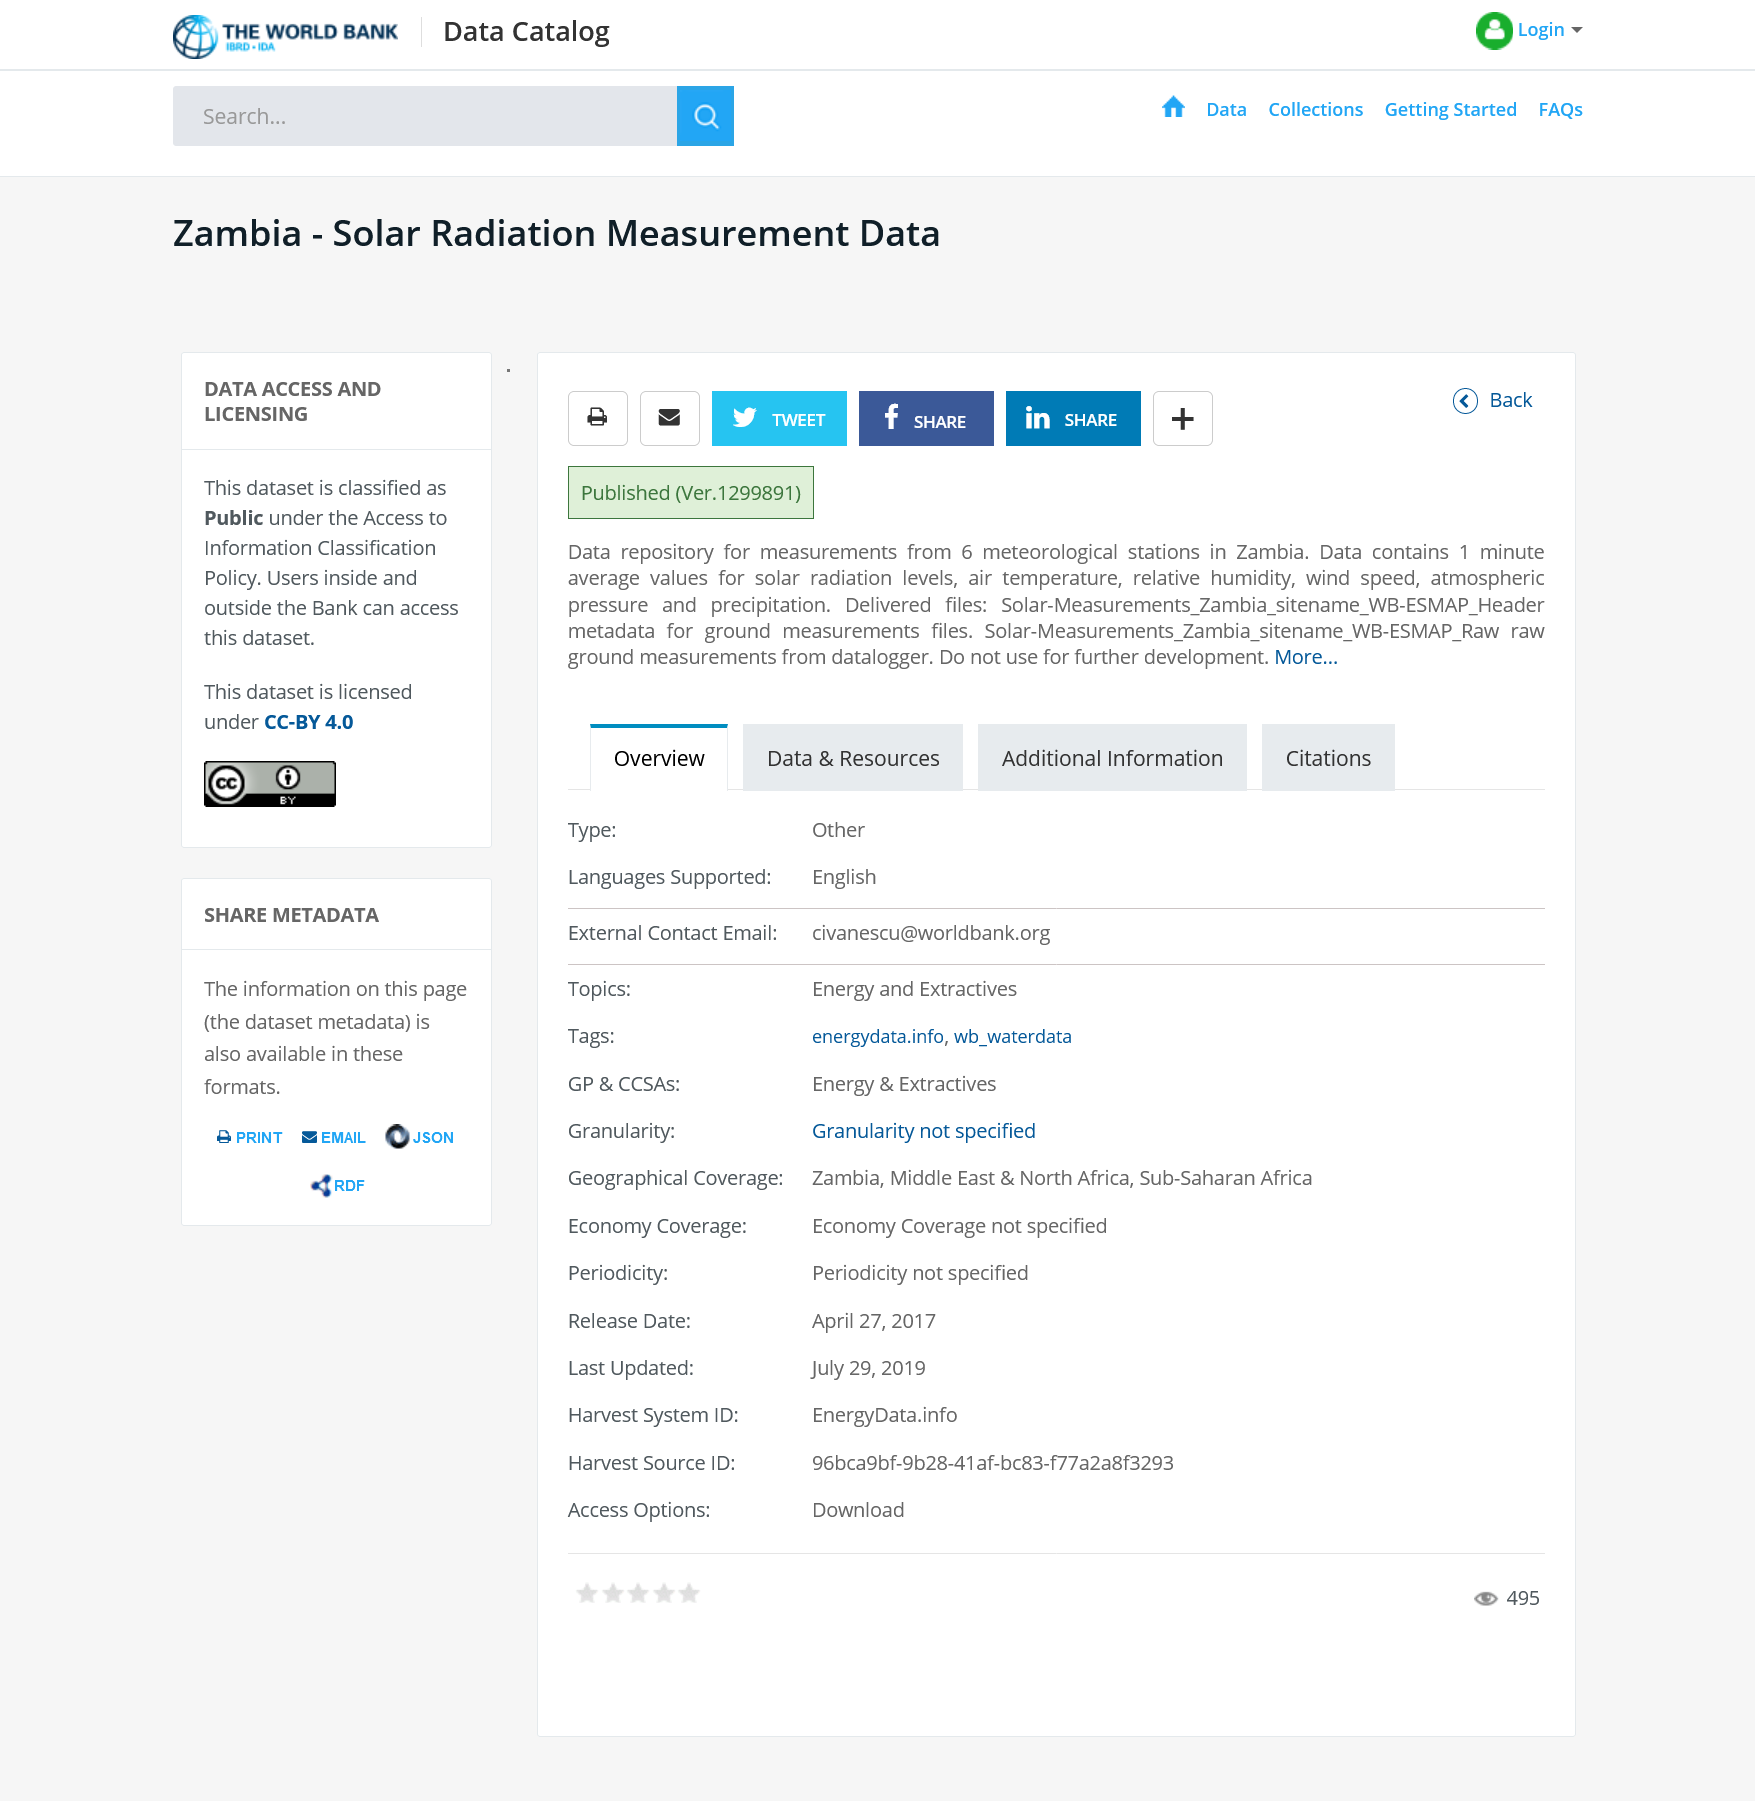Give some essential details in this illustration. The classification policy allows access to the information by both bank employees and external users. There are a total of 6 meteorological stations in Zambia. Zambia is a country located in southern Africa, known for its solar radiation measurement data. This data is used to study the effects of solar radiation on the environment and human activity within the region. 